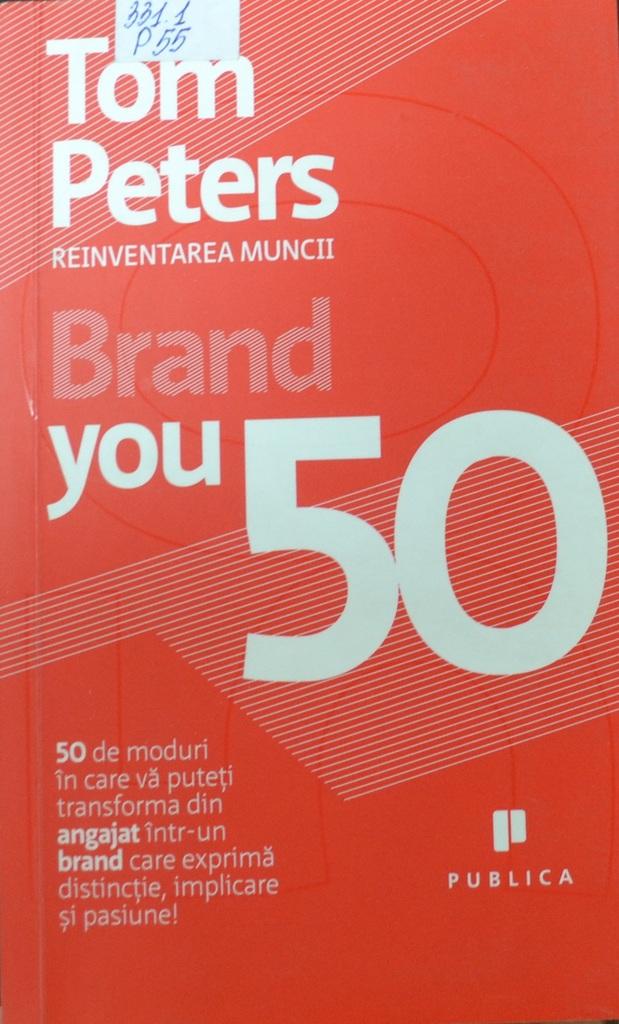What's the name of the publisher?
Keep it short and to the point. Publica. The author of this is?
Provide a short and direct response. Tom peters. 